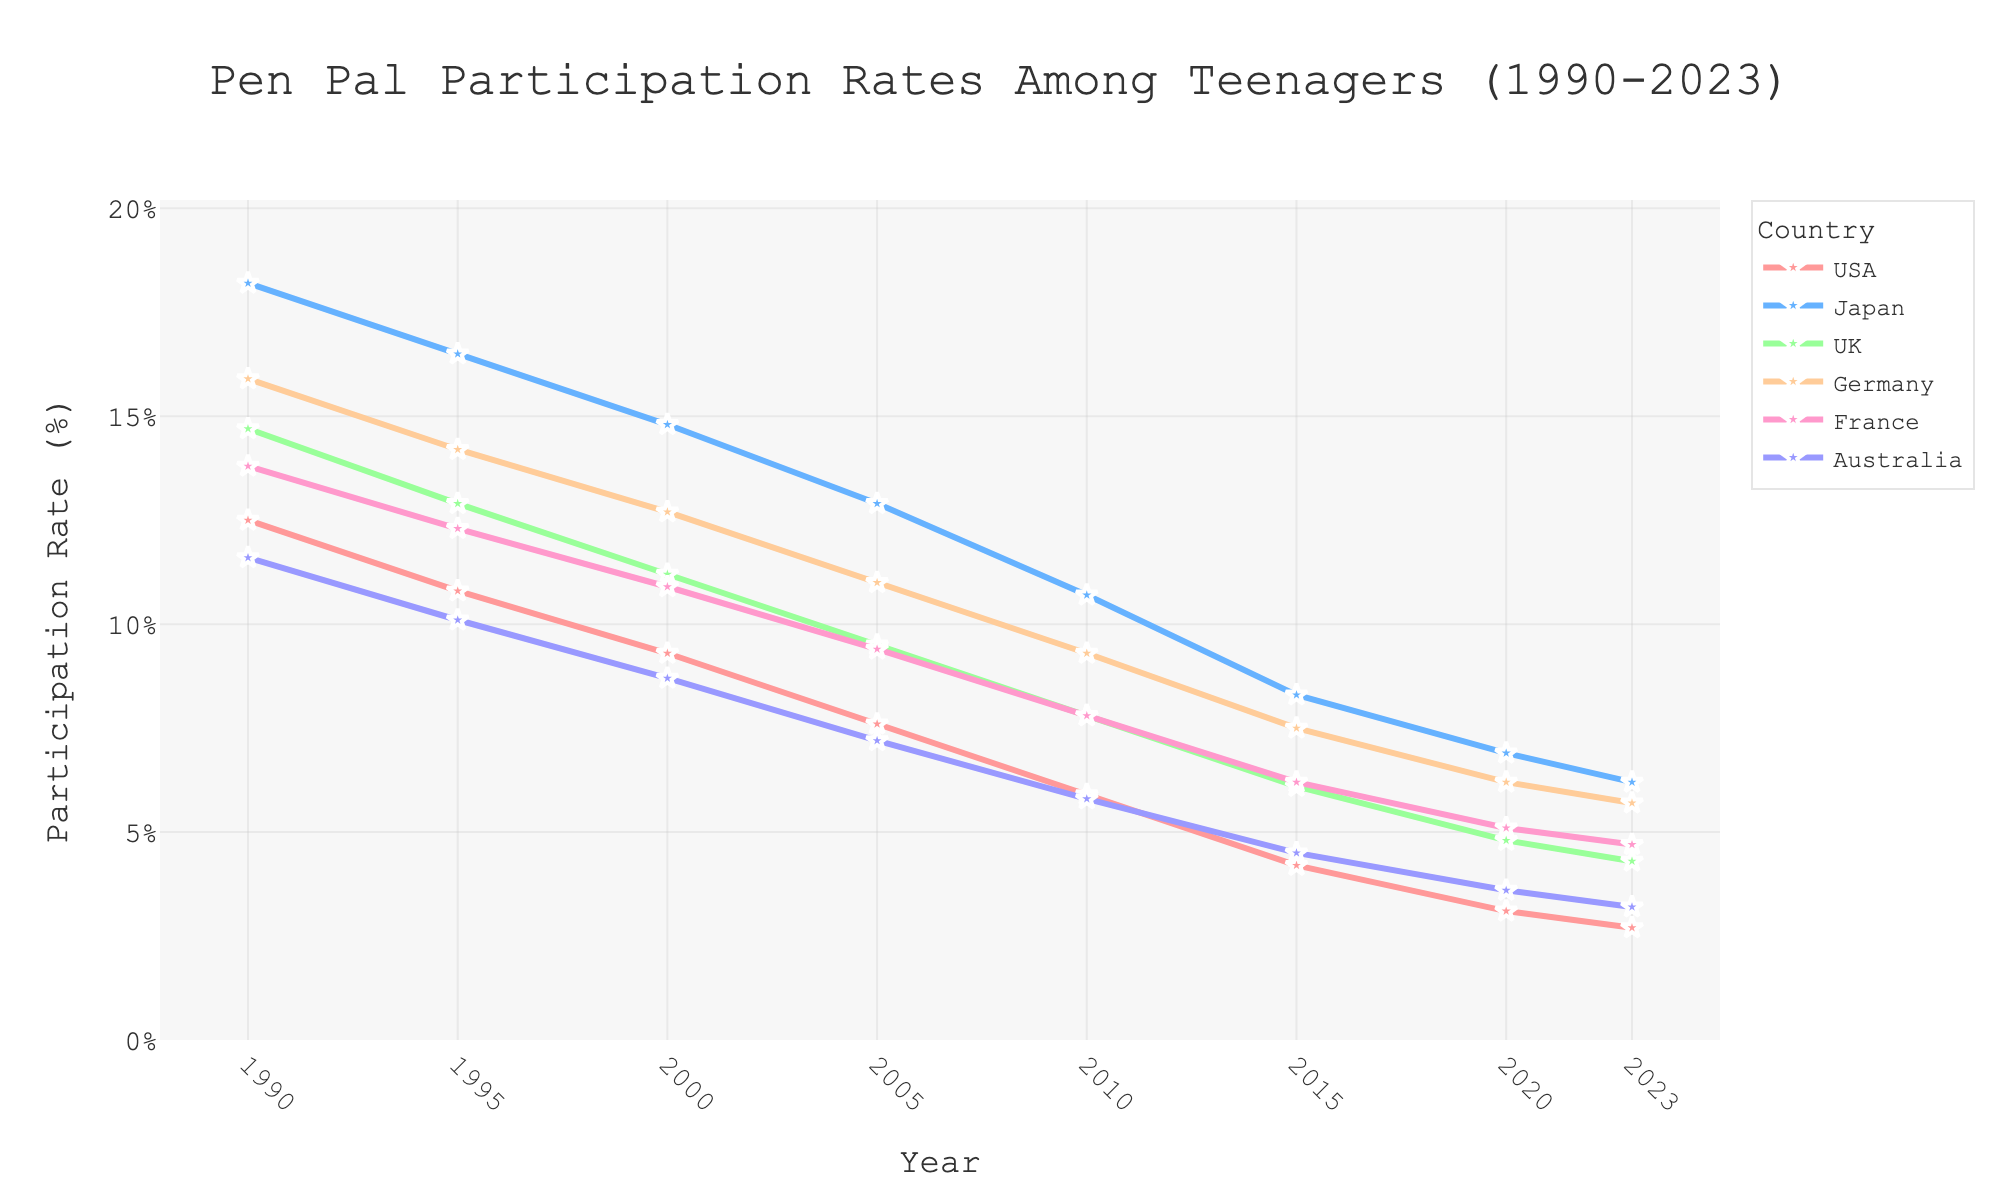What country had the highest pen pal participation rate in 1990? Look at the participation rates for each country in 1990 and identify the highest value. Japan had the highest value at 18.2%.
Answer: Japan Which country showed the steepest decline in pen pal participation rates from 1990 to 2023? Calculate the difference in participation rates from 1990 to 2023 for each country and see which country has the largest decrease. The USA showed the steepest decline from 12.5% in 1990 to 2.7% in 2023, a drop of 9.8%.
Answer: USA In which year did France's participation rate drop below 10%? Observe France's participation rates over the years and find the first year where it falls below 10%. France's rate dropped below 10% in the year 2000.
Answer: 2000 Compare the pen pal participation rates of Germany and the UK in 2010. Which country had a higher rate? Look at the participation rates for Germany and the UK in 2010 and compare the values. Germany's rate was 9.3% and the UK's was 7.8%. Germany's rate was higher.
Answer: Germany What was the average pen pal participation rate across all countries in 2000? Add up the participation rates for all the countries in 2000, then divide by the number of countries. (9.3 + 14.8 + 11.2 + 12.7 + 10.9 + 8.7) / 6 = 11.26%.
Answer: 11.26% How did Japan's pen pal participation rate change from 1990 to 2000? Subtract Japan's participation rate in 2000 from its rate in 1990 to get the change. 18.2% - 14.8% = 3.4%. Japan's rate decreased by 3.4%.
Answer: Decreased by 3.4% In which year did all countries have a pen pal participation rate lower than 10%? Scan through each year's data to find the first year where every country's rate is below 10%. This occurred in the year 2020.
Answer: 2020 What is the overall trend in pen pal participation rates among teenagers from 1990 to 2023? Observe the general direction and pattern of the lines over the years. The overall trend shows a steady decline in pen pal participation rates for all the countries.
Answer: Declining 